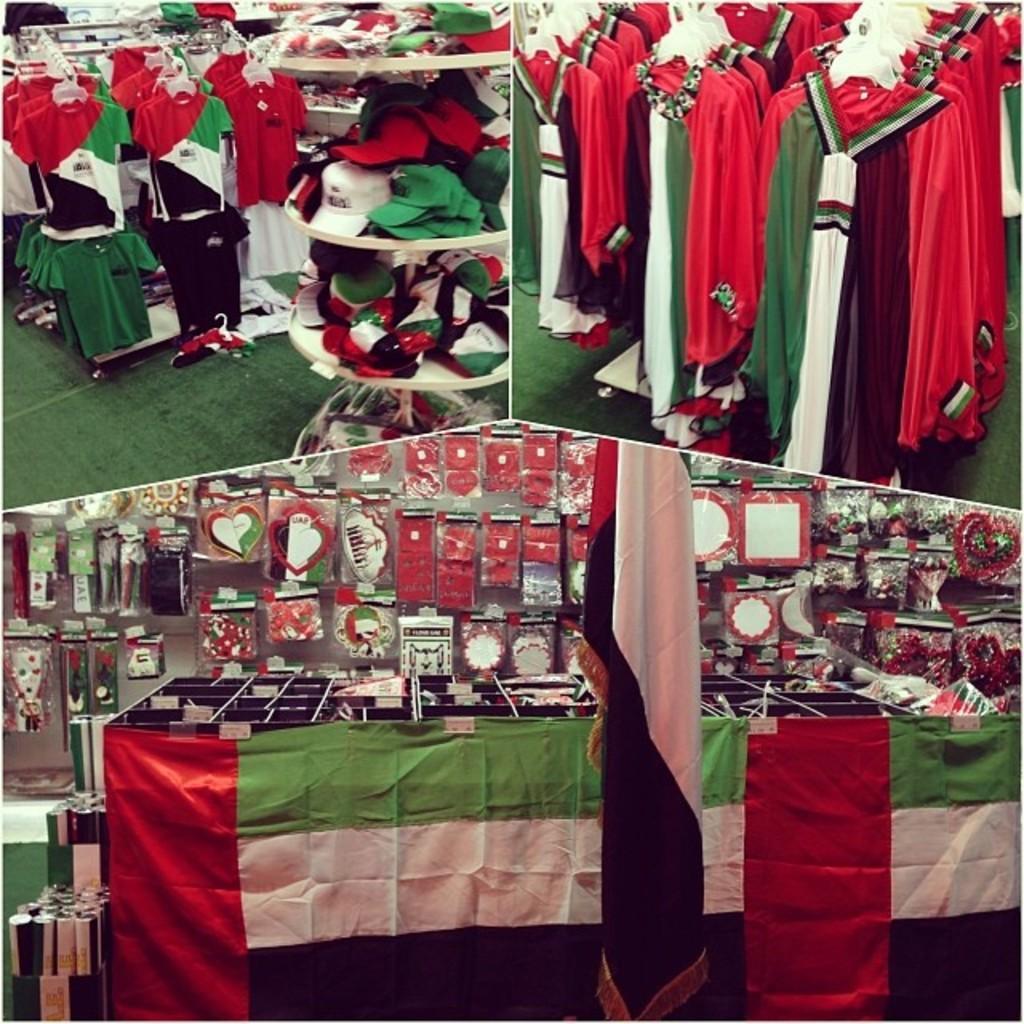Could you give a brief overview of what you see in this image? This picture shows a collage of different pictures. We see clothes to the Hanger and caps and we see flags. 